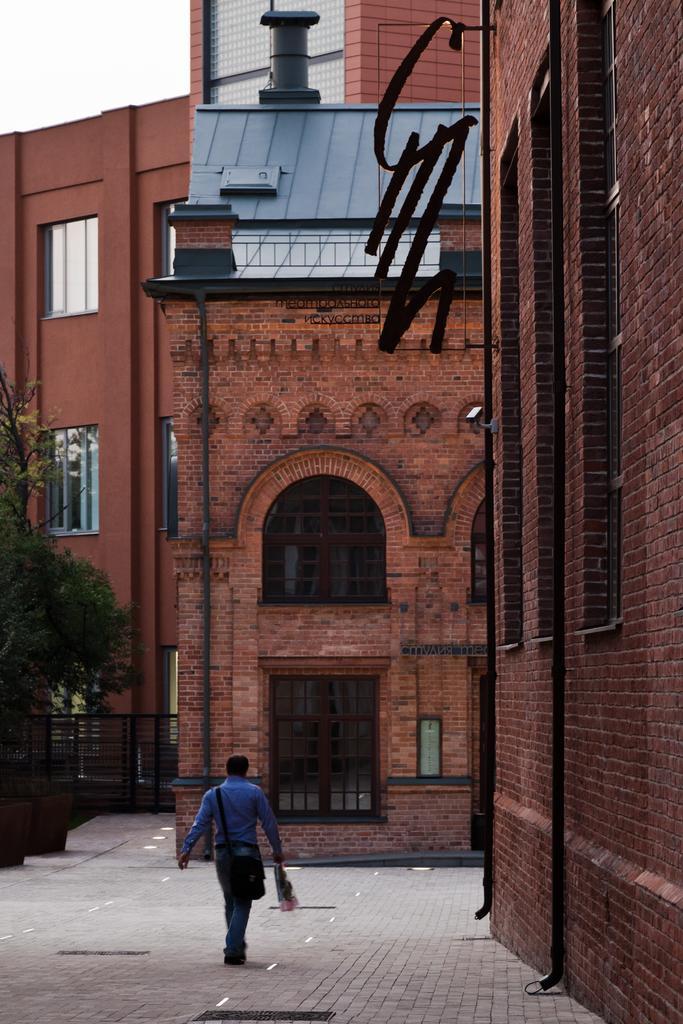In one or two sentences, can you explain what this image depicts? In this image we can see a man with handbag and object in hand, there are buildings, trees and pipes attached to the building and there is an iron railing. 